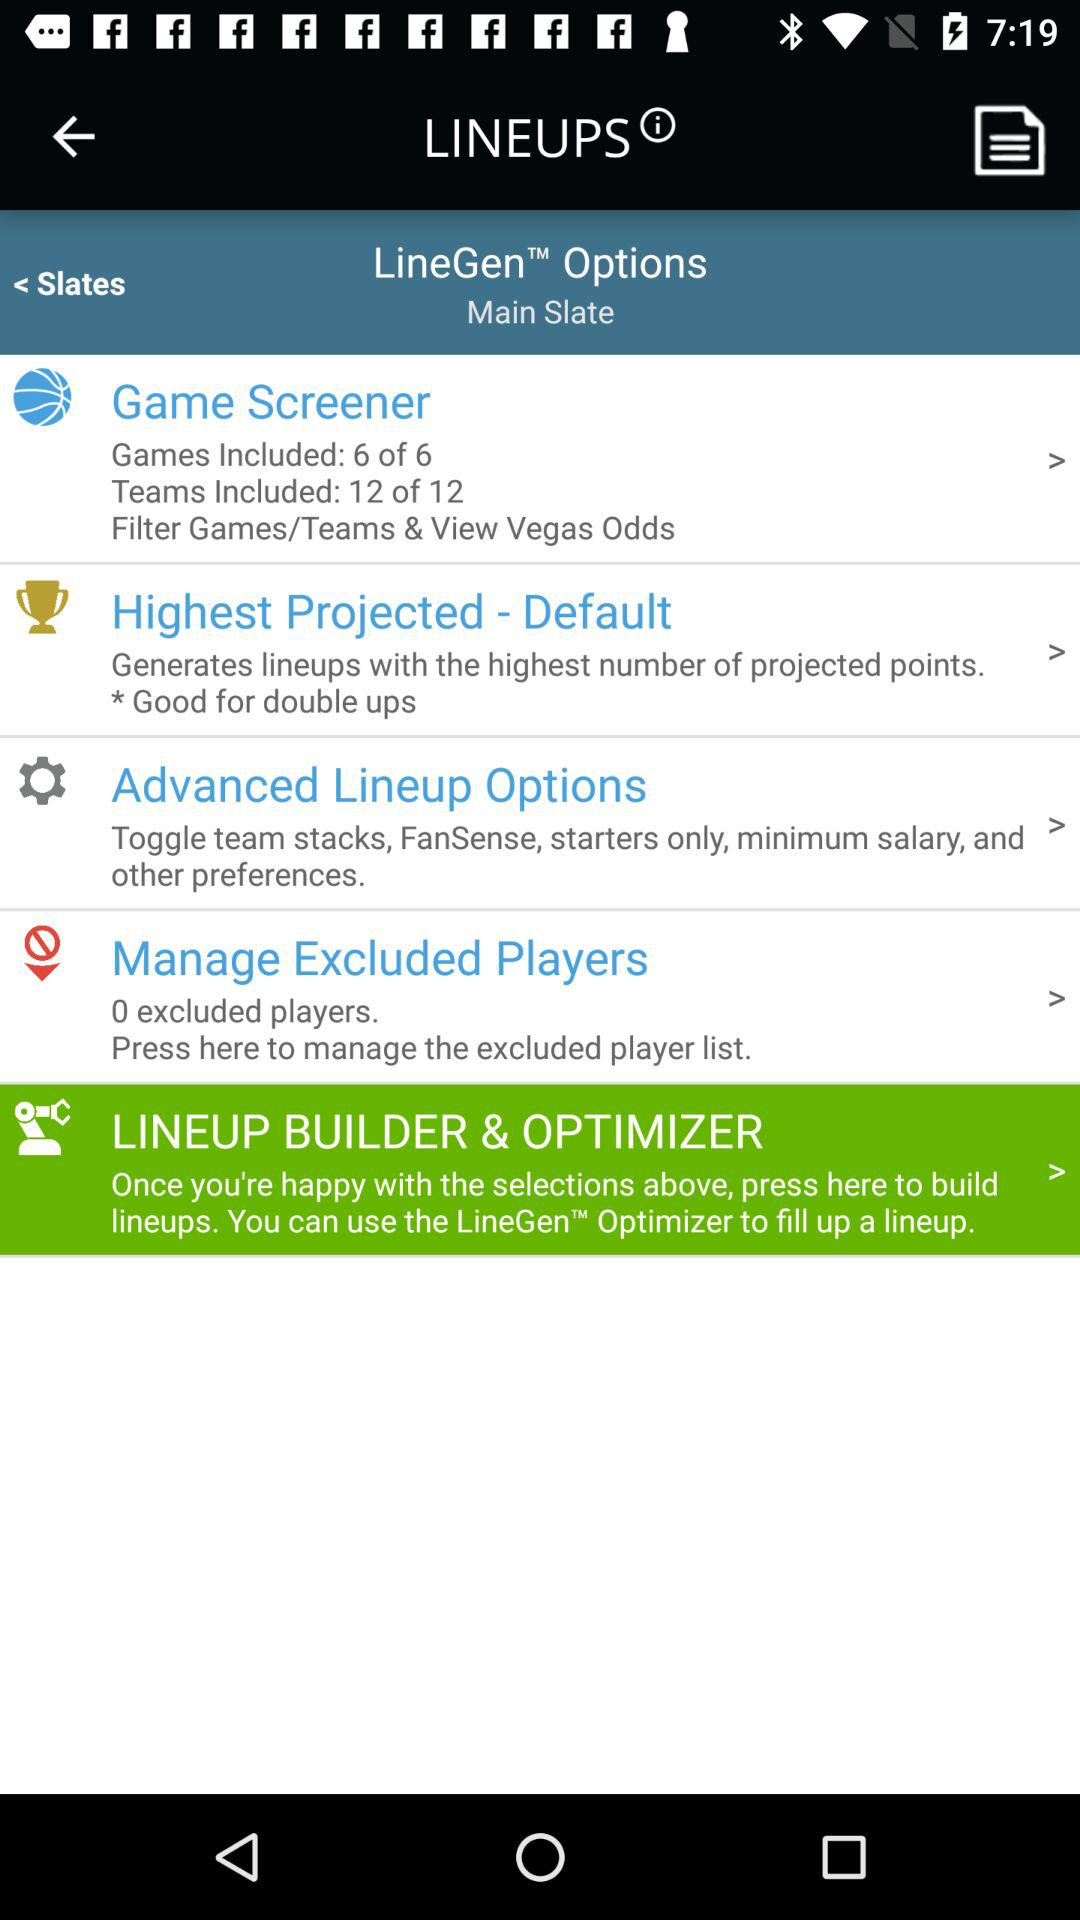How many more teams are included than games?
Answer the question using a single word or phrase. 6 